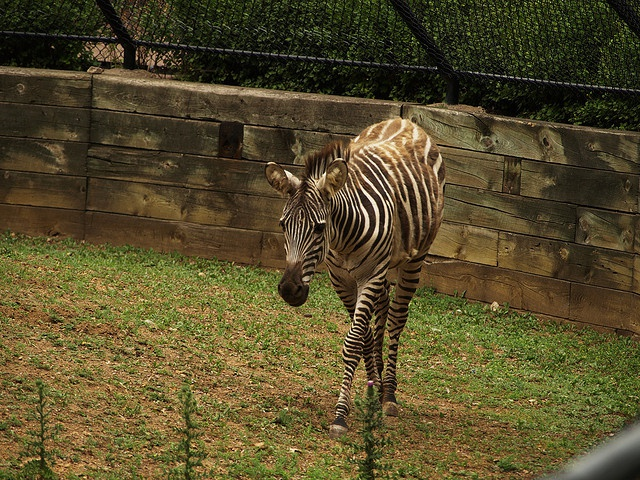Describe the objects in this image and their specific colors. I can see a zebra in black, olive, maroon, and tan tones in this image. 